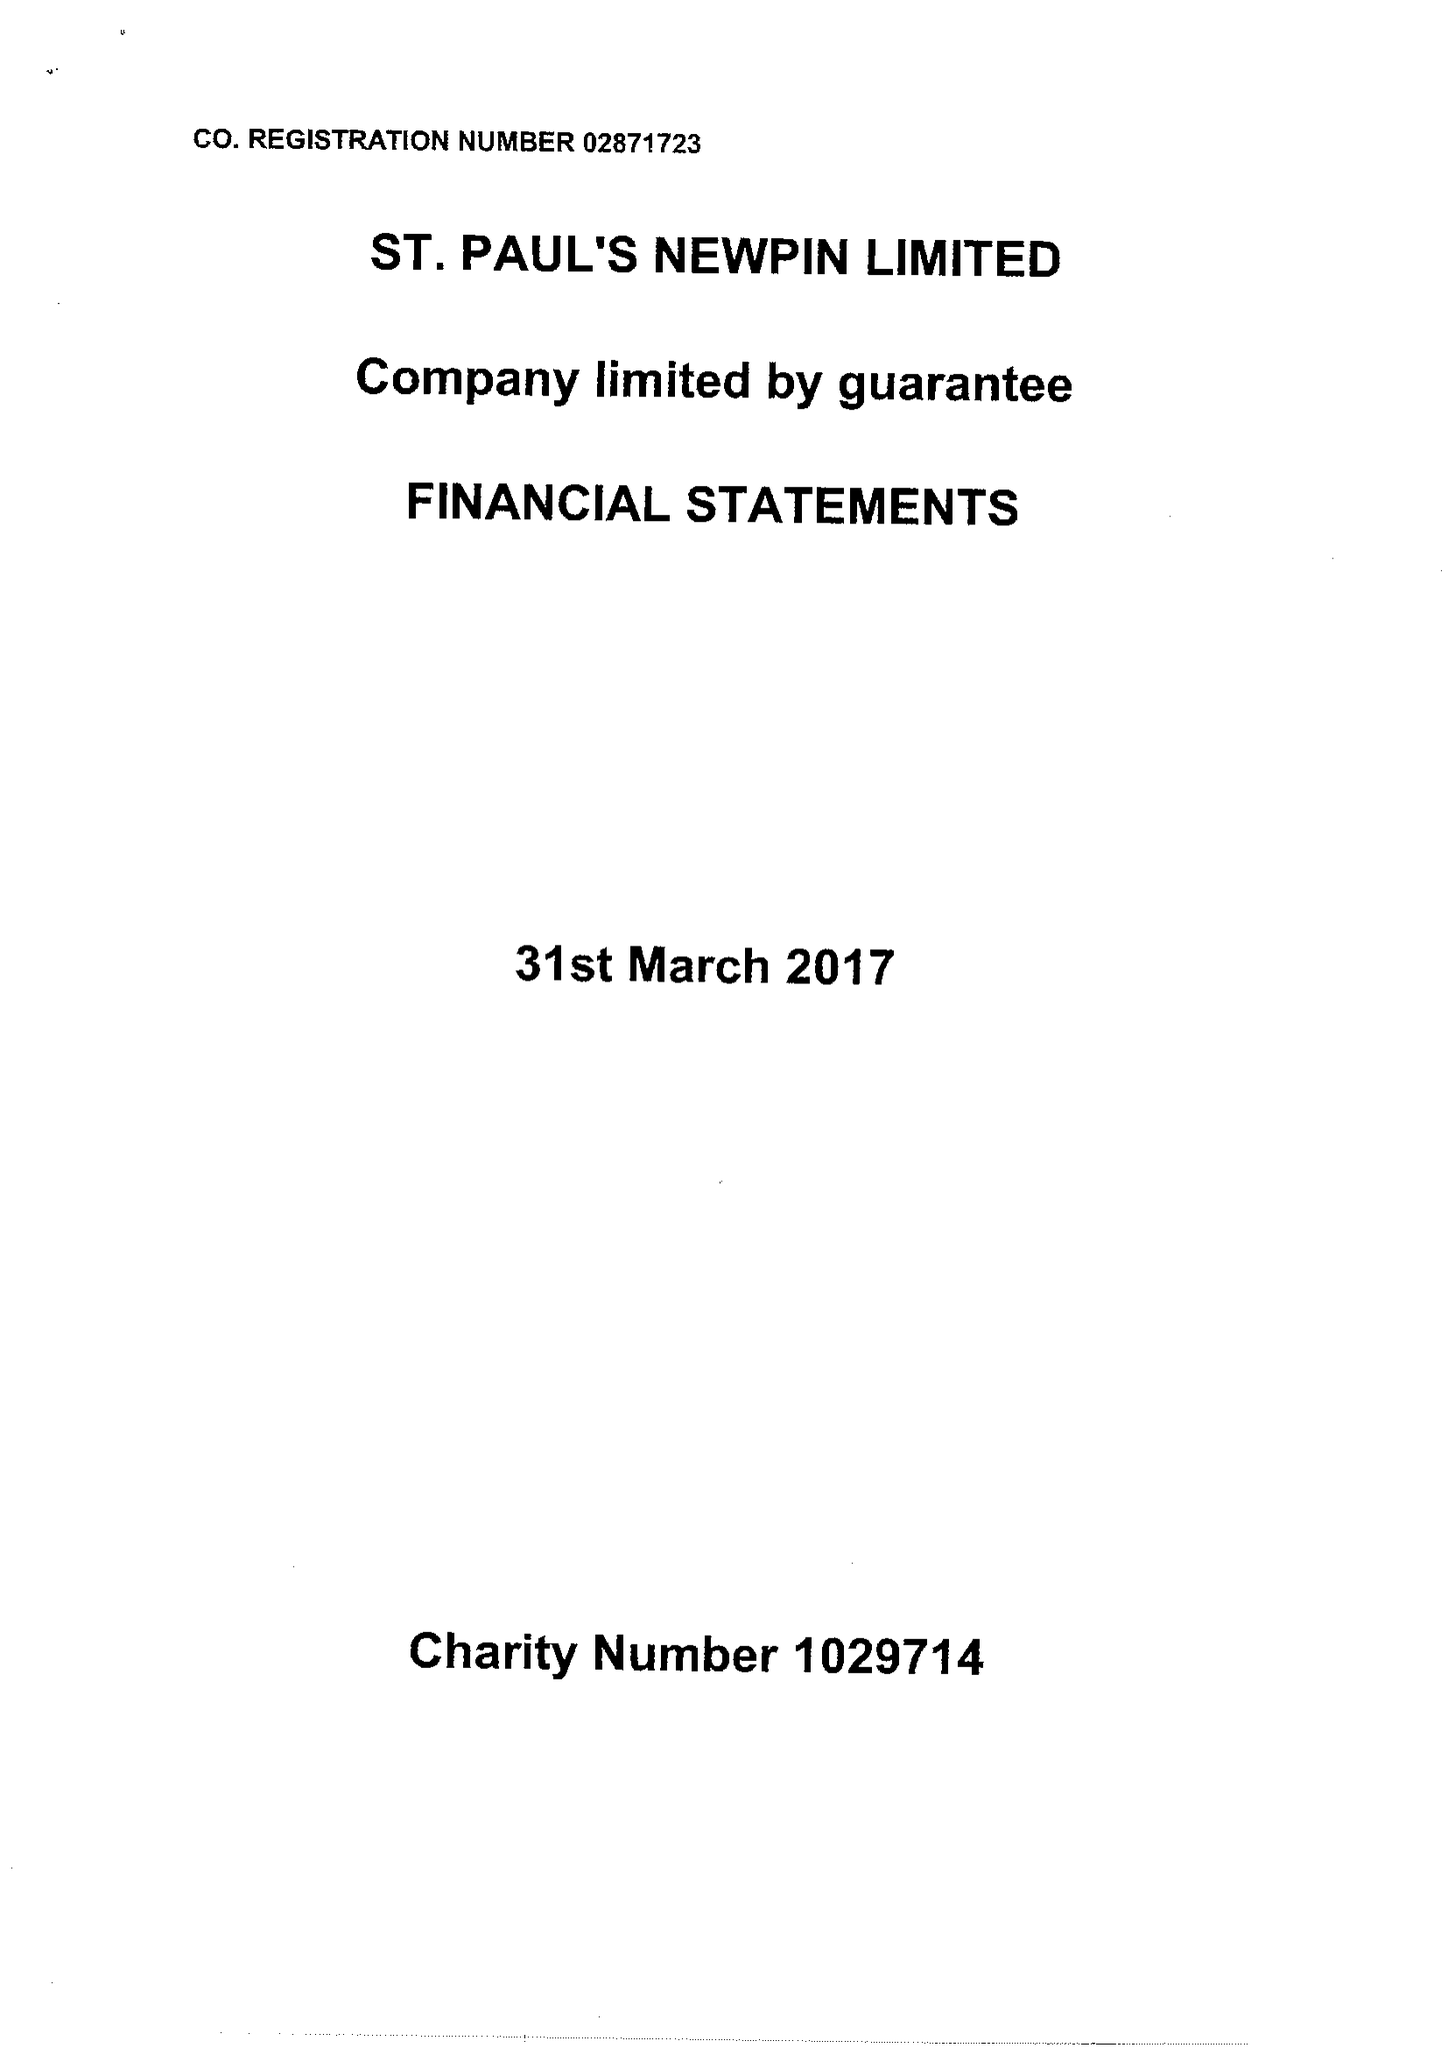What is the value for the charity_number?
Answer the question using a single word or phrase. 1029714 